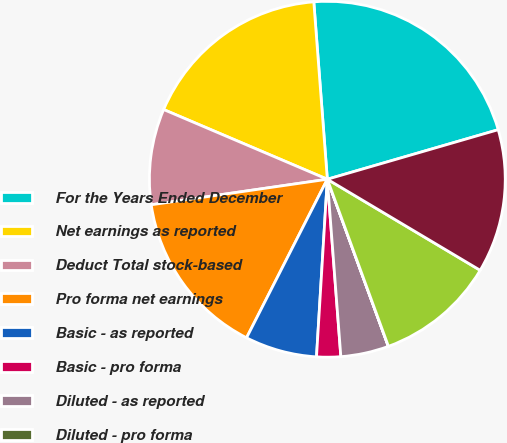Convert chart. <chart><loc_0><loc_0><loc_500><loc_500><pie_chart><fcel>For the Years Ended December<fcel>Net earnings as reported<fcel>Deduct Total stock-based<fcel>Pro forma net earnings<fcel>Basic - as reported<fcel>Basic - pro forma<fcel>Diluted - as reported<fcel>Diluted - pro forma<fcel>Basic<fcel>Diluted<nl><fcel>21.72%<fcel>17.38%<fcel>8.7%<fcel>15.21%<fcel>6.53%<fcel>2.18%<fcel>4.36%<fcel>0.01%<fcel>10.87%<fcel>13.04%<nl></chart> 